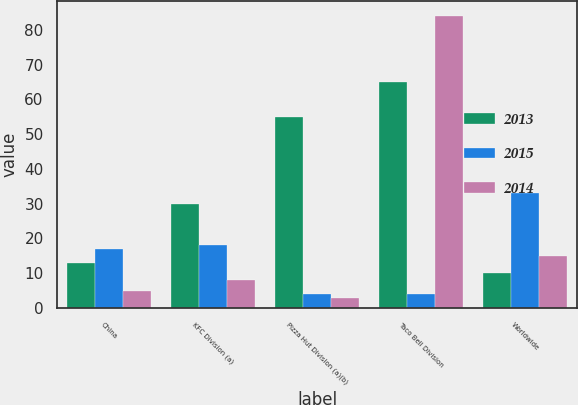Convert chart to OTSL. <chart><loc_0><loc_0><loc_500><loc_500><stacked_bar_chart><ecel><fcel>China<fcel>KFC Division (a)<fcel>Pizza Hut Division (a)(b)<fcel>Taco Bell Division<fcel>Worldwide<nl><fcel>2013<fcel>13<fcel>30<fcel>55<fcel>65<fcel>10<nl><fcel>2015<fcel>17<fcel>18<fcel>4<fcel>4<fcel>33<nl><fcel>2014<fcel>5<fcel>8<fcel>3<fcel>84<fcel>15<nl></chart> 